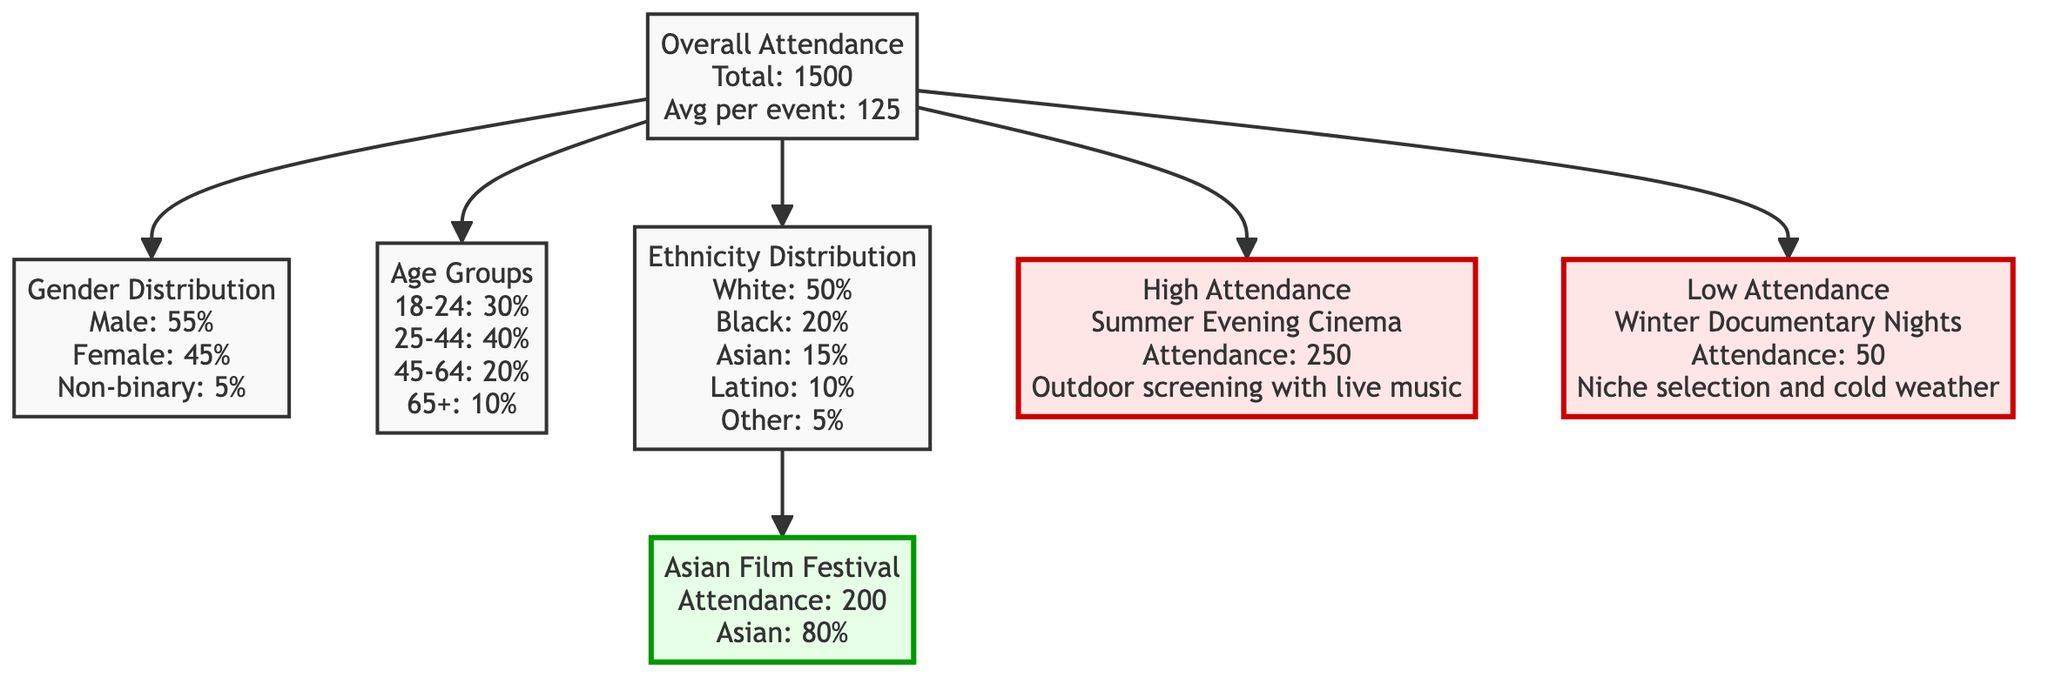What is the total attendance for the year? The overall attendance node states "Total: 1500," which directly indicates the total number of attendees over the past year.
Answer: 1500 What percentage of attendees identified as male? The gender distribution node provides the information "Male: 55%," indicating the proportion of male attendees among the entire population.
Answer: 55% What is the average attendance per event? The overall attendance node also mentions "Avg per event: 125," clarifying how attendance averages out across all events held in the year.
Answer: 125 Which event had the highest attendance? The high attendance node cites "Summer Evening Cinema" with an attendance of "250," directly highlighting the specific event that garnered the most attendees.
Answer: Summer Evening Cinema What age group comprised 40% of the attendees? The age groups node lists "25-44: 40%," indicating that the 25-44 age category made up 40% of those attending the neighborhood film events.
Answer: 25-44 What is the attendance at the Asian Film Festival, which is an outlier? The outlier node for the Asian Film Festival specifies "Attendance: 200," which shows the attendance figure for this specific event that stands out from others.
Answer: 200 What is the total percentage of attendees who identified as Latino? The ethnicity distribution node indicates "Latino: 10%," reflecting the percentage of attendees who belong to the Latino ethnic group within the overall demographic.
Answer: 10% Why might "Winter Documentary Nights" have low attendance? The low attendance node states "Attendance: 50" and mentions "Niche selection and cold weather," implying these factors likely contributed to lower overall participation in this event.
Answer: Niche selection and cold weather How does the attendance of the High Attendance events compare to Low Attendance events? Comparing the readings, the high attendance event had "250," while the low attendance event only had "50." This indicates a significant difference in attendance numbers, showing that high attendance events attract five times as many attendees as low attendance ones.
Answer: 5 times What percentage of attendees were categorized as Asian? The ethnicity distribution node notes "Asian: 15%," which directly provides the percentage of attendees belonging to the Asian ethnicity.
Answer: 15% 